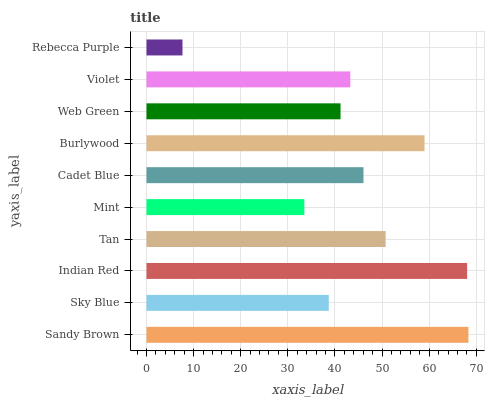Is Rebecca Purple the minimum?
Answer yes or no. Yes. Is Sandy Brown the maximum?
Answer yes or no. Yes. Is Sky Blue the minimum?
Answer yes or no. No. Is Sky Blue the maximum?
Answer yes or no. No. Is Sandy Brown greater than Sky Blue?
Answer yes or no. Yes. Is Sky Blue less than Sandy Brown?
Answer yes or no. Yes. Is Sky Blue greater than Sandy Brown?
Answer yes or no. No. Is Sandy Brown less than Sky Blue?
Answer yes or no. No. Is Cadet Blue the high median?
Answer yes or no. Yes. Is Violet the low median?
Answer yes or no. Yes. Is Mint the high median?
Answer yes or no. No. Is Sky Blue the low median?
Answer yes or no. No. 